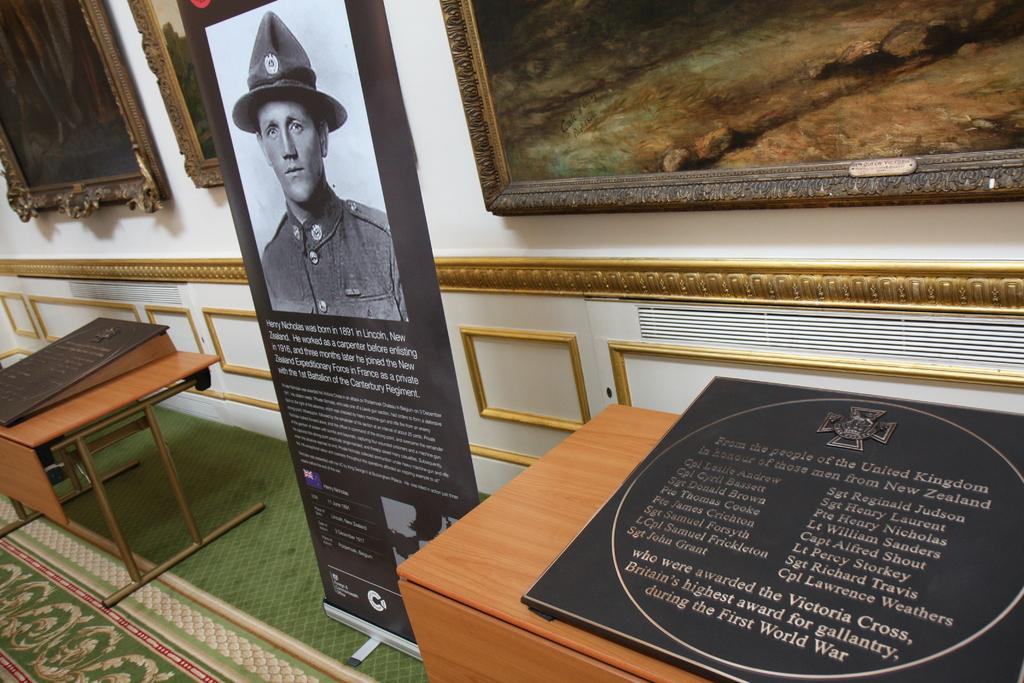What is the main setting of the image? There is a room in the image. Who or what is present in the room? There is a person in the room. What objects can be seen in the room? There is a photo frame and a name board in the room. What piece of furniture is present in the room? There is a table in the room. What type of balloon does the person in the image wish to have? There is no balloon present in the image, so it is not possible to determine what type of balloon the person might wish for. 